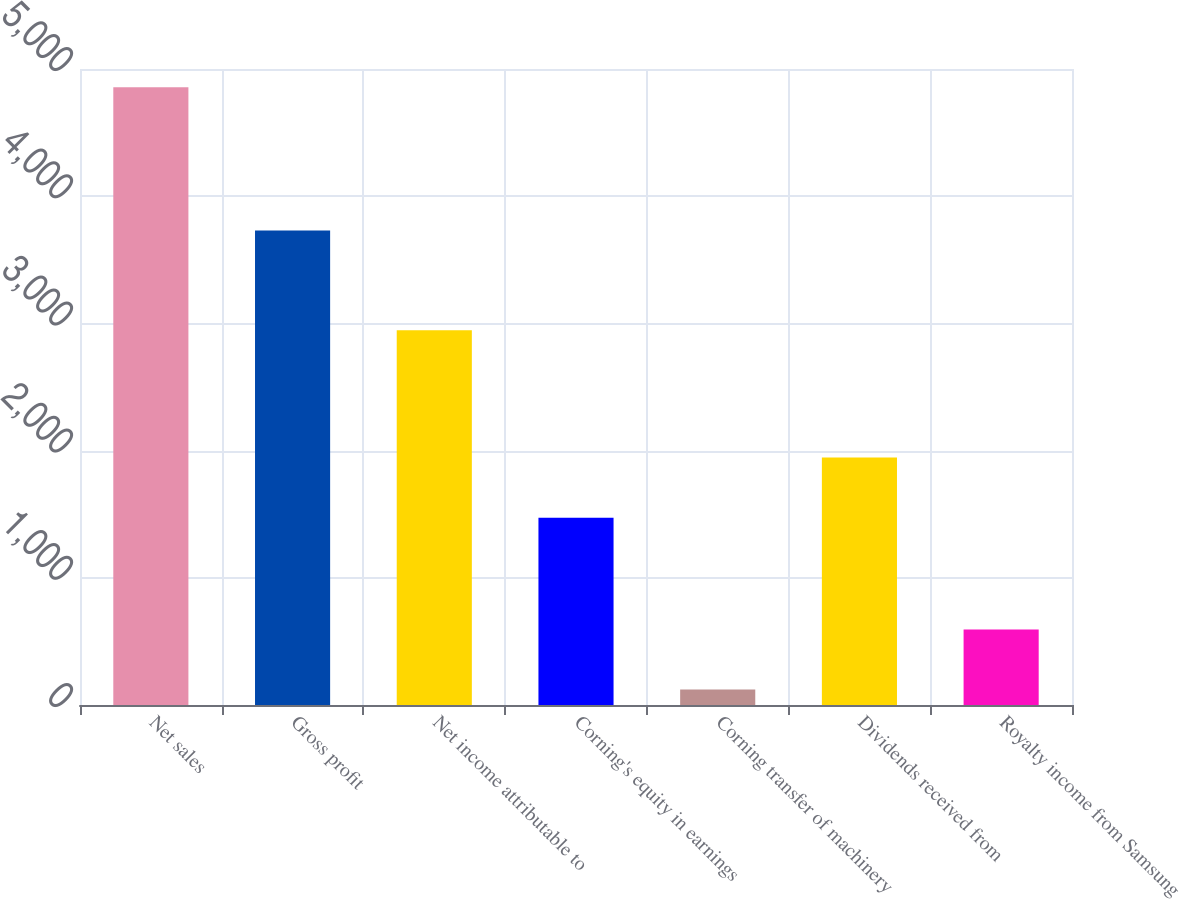Convert chart to OTSL. <chart><loc_0><loc_0><loc_500><loc_500><bar_chart><fcel>Net sales<fcel>Gross profit<fcel>Net income attributable to<fcel>Corning's equity in earnings<fcel>Corning transfer of machinery<fcel>Dividends received from<fcel>Royalty income from Samsung<nl><fcel>4856<fcel>3731<fcel>2946<fcel>1473<fcel>121<fcel>1946.5<fcel>594.5<nl></chart> 